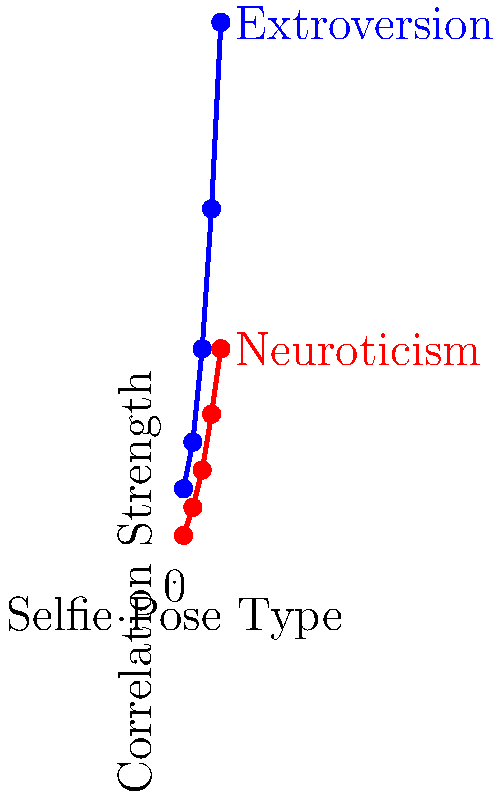Based on the graph showing the correlation between selfie pose types and personality traits, which personality trait demonstrates a stronger positive correlation with increasing selfie pose complexity? To answer this question, we need to analyze the trends in the graph:

1. The graph shows two lines representing different personality traits: Extroversion (blue) and Neuroticism (red).
2. The x-axis represents different selfie pose types, likely increasing in complexity from 1 to 5.
3. The y-axis represents the correlation strength between the pose type and the personality trait.

4. Examining the blue line (Extroversion):
   - It starts at a lower point and rises steeply as the pose type increases.
   - The correlation strength increases from about 10 to 60 across the five pose types.

5. Examining the red line (Neuroticism):
   - It also starts at a lower point and rises, but less steeply than the blue line.
   - The correlation strength increases from about 5 to 25 across the five pose types.

6. Comparing the two lines:
   - Both show positive correlations (upward slopes).
   - The blue line (Extroversion) has a steeper slope and reaches a higher correlation strength.

7. A steeper slope and higher endpoint indicate a stronger positive correlation.

Therefore, Extroversion demonstrates a stronger positive correlation with increasing selfie pose complexity.
Answer: Extroversion 